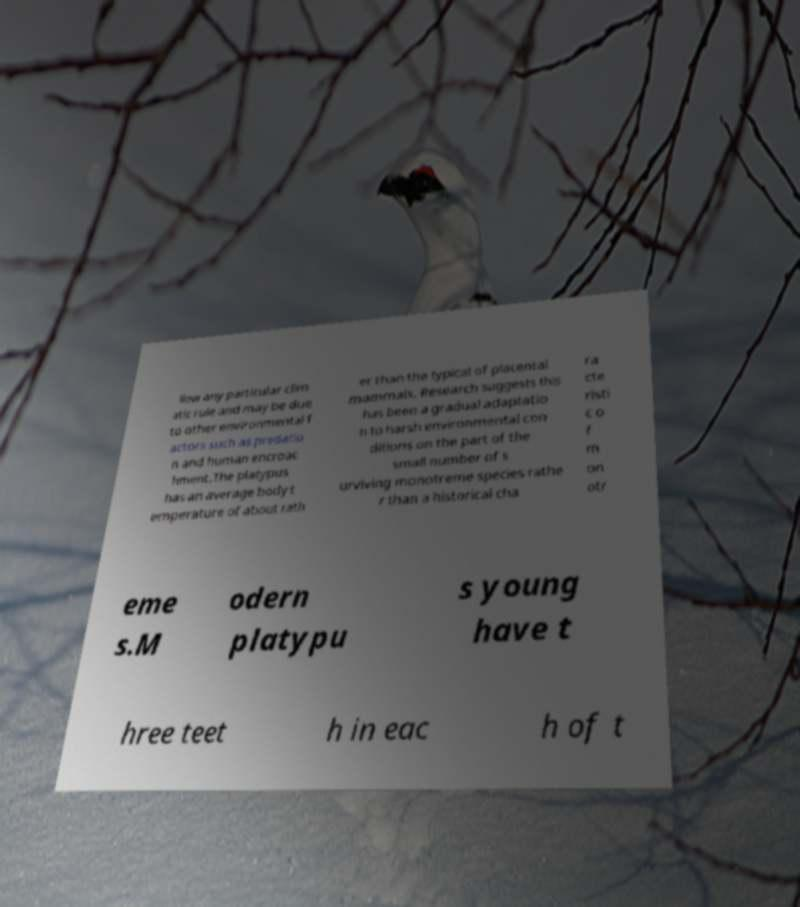Could you extract and type out the text from this image? llow any particular clim atic rule and may be due to other environmental f actors such as predatio n and human encroac hment.The platypus has an average body t emperature of about rath er than the typical of placental mammals. Research suggests this has been a gradual adaptatio n to harsh environmental con ditions on the part of the small number of s urviving monotreme species rathe r than a historical cha ra cte risti c o f m on otr eme s.M odern platypu s young have t hree teet h in eac h of t 